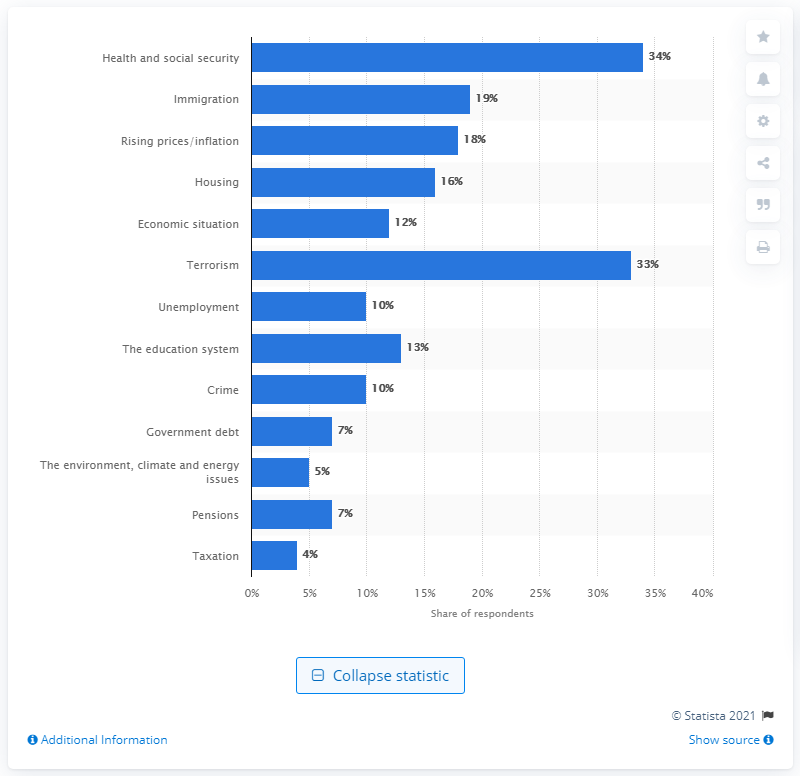Mention a couple of crucial points in this snapshot. The most commonly asked issue of the UK public in May 2017 was terrorism. 